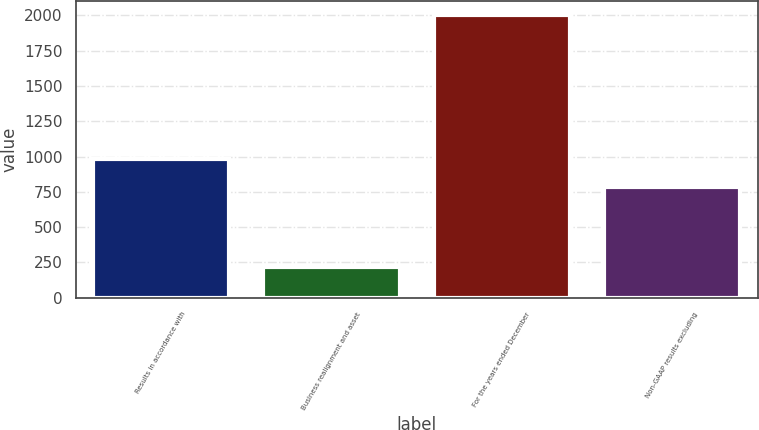Convert chart to OTSL. <chart><loc_0><loc_0><loc_500><loc_500><bar_chart><fcel>Results in accordance with<fcel>Business realignment and asset<fcel>For the years ended December<fcel>Non-GAAP results excluding<nl><fcel>982.65<fcel>220.55<fcel>2003<fcel>784.6<nl></chart> 